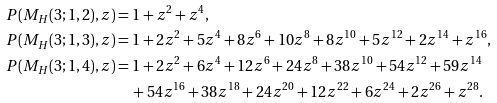Convert formula to latex. <formula><loc_0><loc_0><loc_500><loc_500>P ( M _ { H } ( 3 ; 1 , 2 ) , z ) & = 1 + z ^ { 2 } + z ^ { 4 } , \\ P ( M _ { H } ( 3 ; 1 , 3 ) , z ) & = 1 + 2 z ^ { 2 } + 5 z ^ { 4 } + 8 z ^ { 6 } + 1 0 z ^ { 8 } + 8 z ^ { 1 0 } + 5 z ^ { 1 2 } + 2 z ^ { 1 4 } + z ^ { 1 6 } , \\ P ( M _ { H } ( 3 ; 1 , 4 ) , z ) & = 1 + 2 z ^ { 2 } + 6 z ^ { 4 } + 1 2 z ^ { 6 } + 2 4 z ^ { 8 } + 3 8 z ^ { 1 0 } + 5 4 z ^ { 1 2 } + 5 9 z ^ { 1 4 } \\ & \quad + 5 4 z ^ { 1 6 } + 3 8 z ^ { 1 8 } + 2 4 z ^ { 2 0 } + 1 2 z ^ { 2 2 } + 6 z ^ { 2 4 } + 2 z ^ { 2 6 } + z ^ { 2 8 } .</formula> 